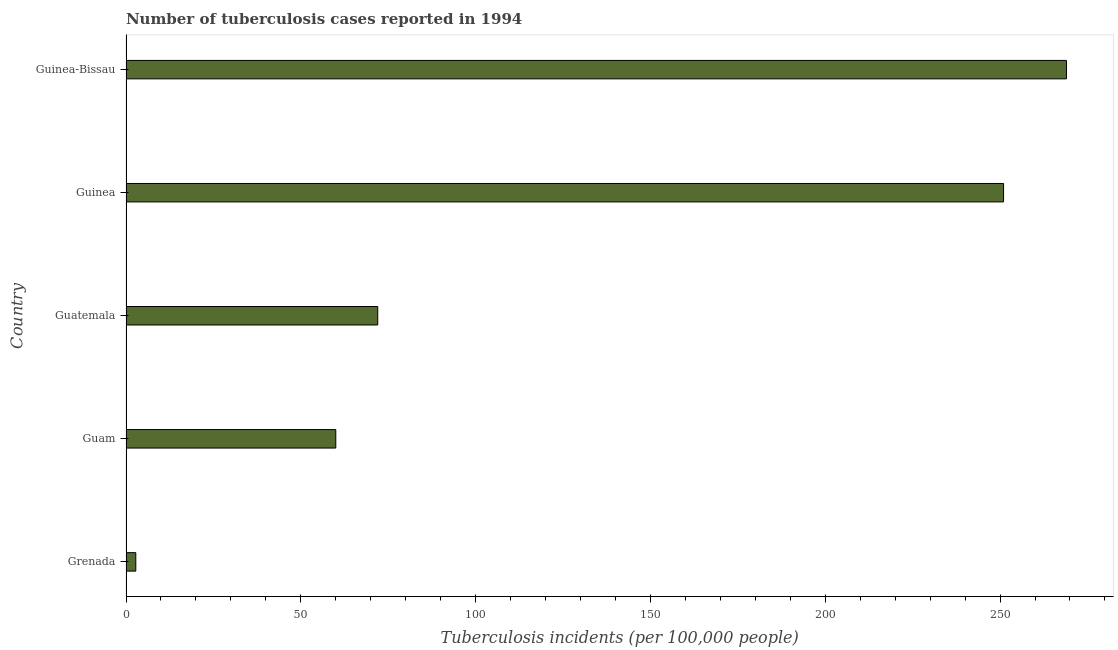Does the graph contain any zero values?
Your answer should be very brief. No. What is the title of the graph?
Provide a succinct answer. Number of tuberculosis cases reported in 1994. What is the label or title of the X-axis?
Your answer should be compact. Tuberculosis incidents (per 100,0 people). What is the label or title of the Y-axis?
Give a very brief answer. Country. Across all countries, what is the maximum number of tuberculosis incidents?
Give a very brief answer. 269. Across all countries, what is the minimum number of tuberculosis incidents?
Your answer should be compact. 2.8. In which country was the number of tuberculosis incidents maximum?
Offer a very short reply. Guinea-Bissau. In which country was the number of tuberculosis incidents minimum?
Ensure brevity in your answer.  Grenada. What is the sum of the number of tuberculosis incidents?
Give a very brief answer. 654.8. What is the difference between the number of tuberculosis incidents in Grenada and Guinea-Bissau?
Provide a short and direct response. -266.2. What is the average number of tuberculosis incidents per country?
Make the answer very short. 130.96. What is the ratio of the number of tuberculosis incidents in Guam to that in Guatemala?
Your answer should be compact. 0.83. Is the number of tuberculosis incidents in Grenada less than that in Guinea-Bissau?
Offer a terse response. Yes. Is the difference between the number of tuberculosis incidents in Guinea and Guinea-Bissau greater than the difference between any two countries?
Offer a terse response. No. Is the sum of the number of tuberculosis incidents in Guam and Guinea-Bissau greater than the maximum number of tuberculosis incidents across all countries?
Offer a terse response. Yes. What is the difference between the highest and the lowest number of tuberculosis incidents?
Your response must be concise. 266.2. How many countries are there in the graph?
Provide a succinct answer. 5. What is the difference between two consecutive major ticks on the X-axis?
Offer a terse response. 50. Are the values on the major ticks of X-axis written in scientific E-notation?
Your answer should be compact. No. What is the Tuberculosis incidents (per 100,000 people) of Grenada?
Offer a terse response. 2.8. What is the Tuberculosis incidents (per 100,000 people) of Guatemala?
Your answer should be compact. 72. What is the Tuberculosis incidents (per 100,000 people) in Guinea?
Give a very brief answer. 251. What is the Tuberculosis incidents (per 100,000 people) in Guinea-Bissau?
Offer a very short reply. 269. What is the difference between the Tuberculosis incidents (per 100,000 people) in Grenada and Guam?
Provide a succinct answer. -57.2. What is the difference between the Tuberculosis incidents (per 100,000 people) in Grenada and Guatemala?
Ensure brevity in your answer.  -69.2. What is the difference between the Tuberculosis incidents (per 100,000 people) in Grenada and Guinea?
Provide a succinct answer. -248.2. What is the difference between the Tuberculosis incidents (per 100,000 people) in Grenada and Guinea-Bissau?
Provide a short and direct response. -266.2. What is the difference between the Tuberculosis incidents (per 100,000 people) in Guam and Guinea?
Provide a short and direct response. -191. What is the difference between the Tuberculosis incidents (per 100,000 people) in Guam and Guinea-Bissau?
Give a very brief answer. -209. What is the difference between the Tuberculosis incidents (per 100,000 people) in Guatemala and Guinea?
Keep it short and to the point. -179. What is the difference between the Tuberculosis incidents (per 100,000 people) in Guatemala and Guinea-Bissau?
Give a very brief answer. -197. What is the ratio of the Tuberculosis incidents (per 100,000 people) in Grenada to that in Guam?
Your answer should be compact. 0.05. What is the ratio of the Tuberculosis incidents (per 100,000 people) in Grenada to that in Guatemala?
Ensure brevity in your answer.  0.04. What is the ratio of the Tuberculosis incidents (per 100,000 people) in Grenada to that in Guinea?
Keep it short and to the point. 0.01. What is the ratio of the Tuberculosis incidents (per 100,000 people) in Grenada to that in Guinea-Bissau?
Keep it short and to the point. 0.01. What is the ratio of the Tuberculosis incidents (per 100,000 people) in Guam to that in Guatemala?
Ensure brevity in your answer.  0.83. What is the ratio of the Tuberculosis incidents (per 100,000 people) in Guam to that in Guinea?
Offer a terse response. 0.24. What is the ratio of the Tuberculosis incidents (per 100,000 people) in Guam to that in Guinea-Bissau?
Your answer should be very brief. 0.22. What is the ratio of the Tuberculosis incidents (per 100,000 people) in Guatemala to that in Guinea?
Give a very brief answer. 0.29. What is the ratio of the Tuberculosis incidents (per 100,000 people) in Guatemala to that in Guinea-Bissau?
Offer a very short reply. 0.27. What is the ratio of the Tuberculosis incidents (per 100,000 people) in Guinea to that in Guinea-Bissau?
Offer a terse response. 0.93. 